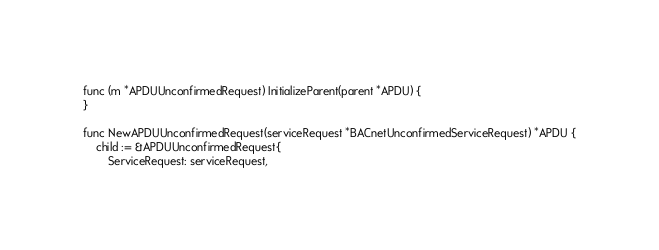Convert code to text. <code><loc_0><loc_0><loc_500><loc_500><_Go_>func (m *APDUUnconfirmedRequest) InitializeParent(parent *APDU) {
}

func NewAPDUUnconfirmedRequest(serviceRequest *BACnetUnconfirmedServiceRequest) *APDU {
	child := &APDUUnconfirmedRequest{
		ServiceRequest: serviceRequest,</code> 